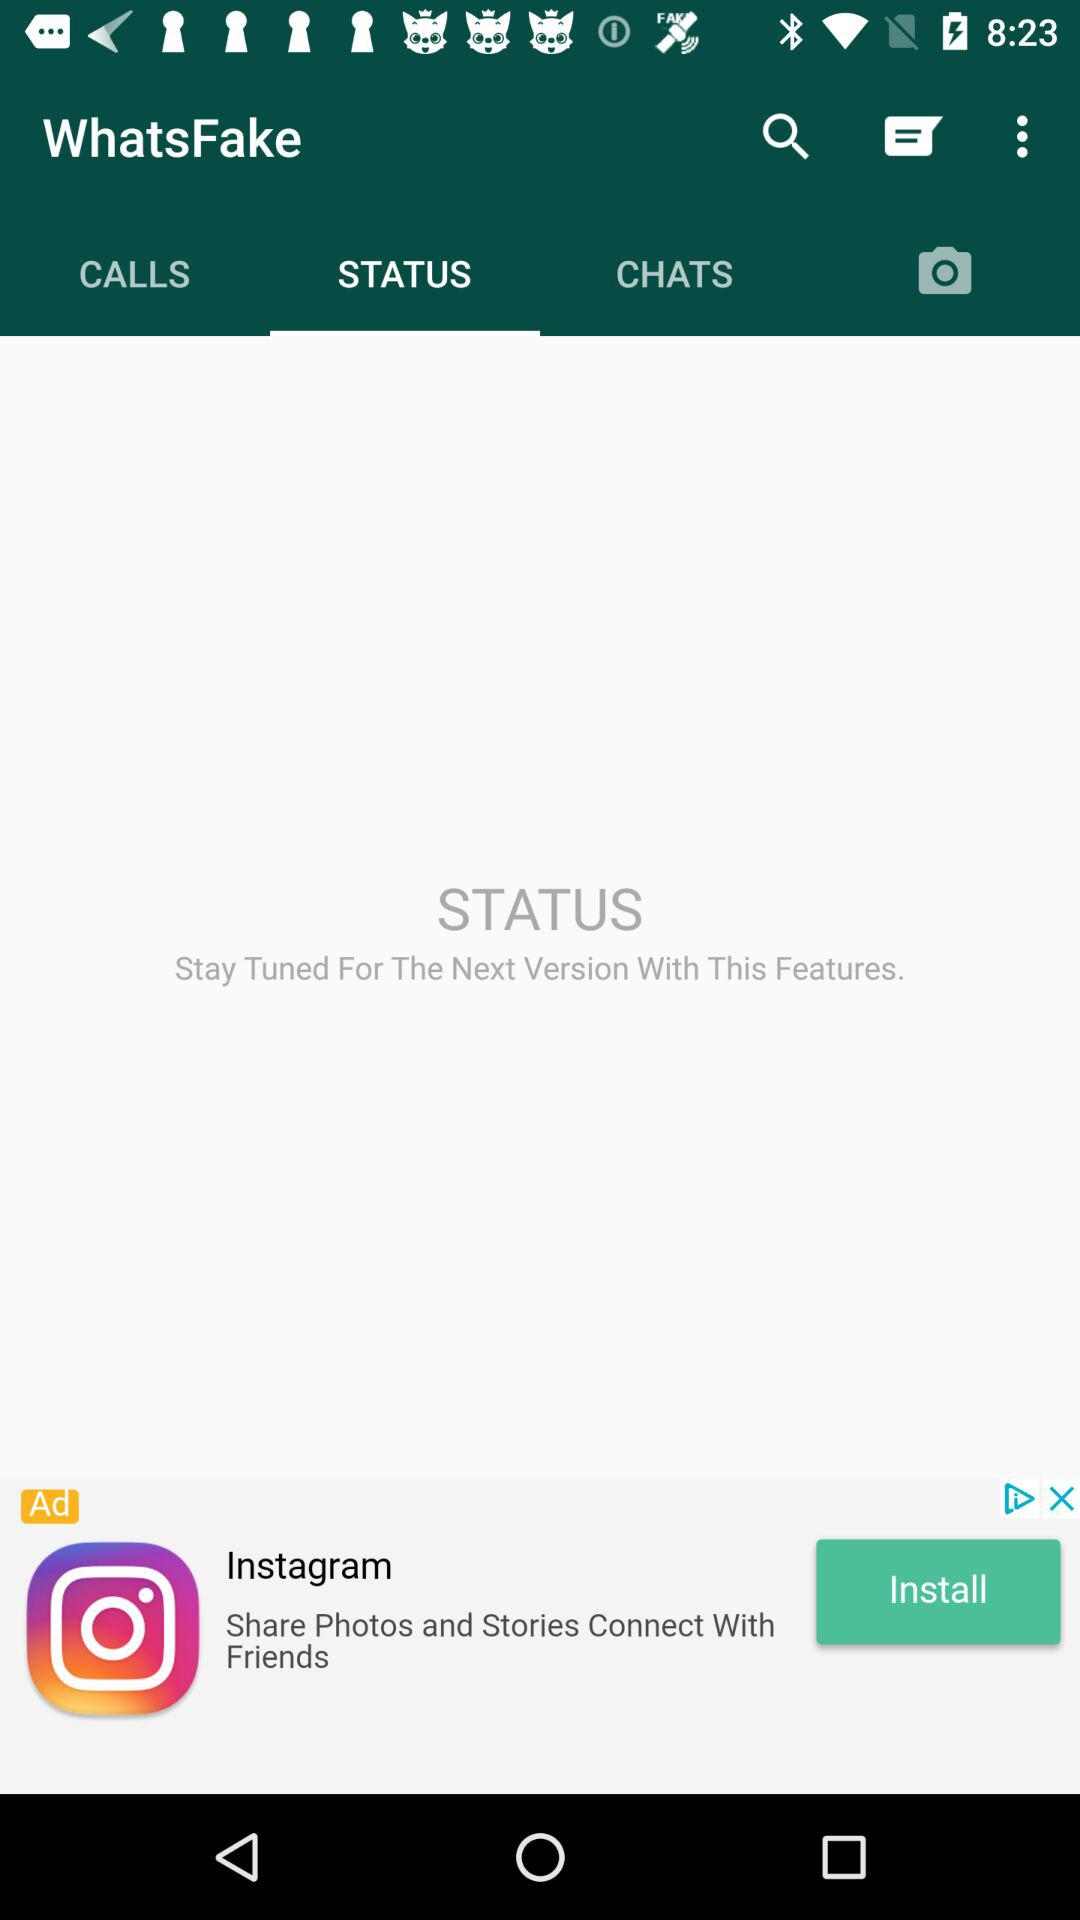What is the name of the application? The name of the application is "WhatsFake". 